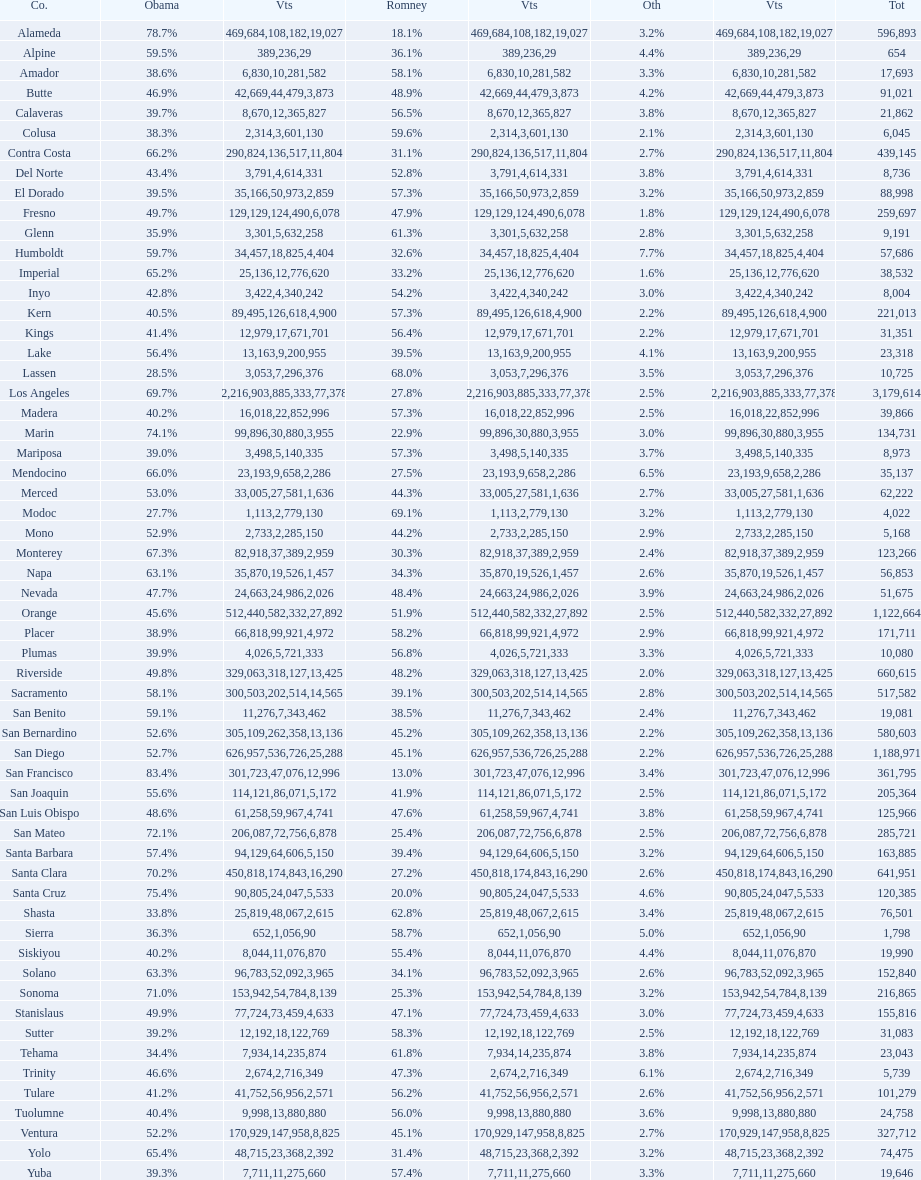What is the number of votes for obama for del norte and el dorado counties? 38957. 